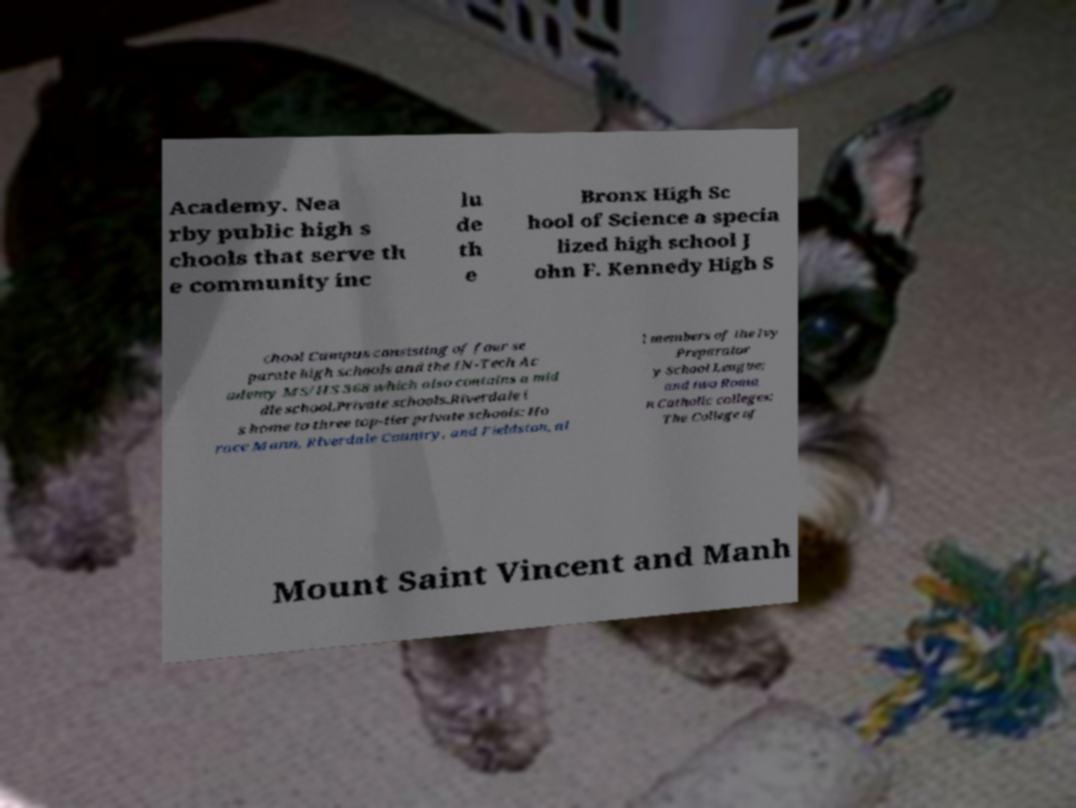I need the written content from this picture converted into text. Can you do that? Academy. Nea rby public high s chools that serve th e community inc lu de th e Bronx High Sc hool of Science a specia lized high school J ohn F. Kennedy High S chool Campus consisting of four se parate high schools and the IN-Tech Ac ademy MS/HS 368 which also contains a mid dle school.Private schools.Riverdale i s home to three top-tier private schools: Ho race Mann, Riverdale Country, and Fieldston, al l members of the Ivy Preparator y School League; and two Roma n Catholic colleges: The College of Mount Saint Vincent and Manh 